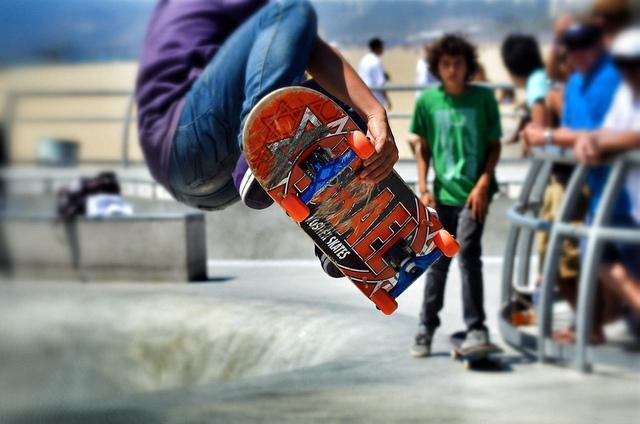Why is the boy wearing purple touching the bottom of the skateboard?
From the following set of four choices, select the accurate answer to respond to the question.
Options: Throw it, clean it, performing tricks, massage it. Performing tricks. 